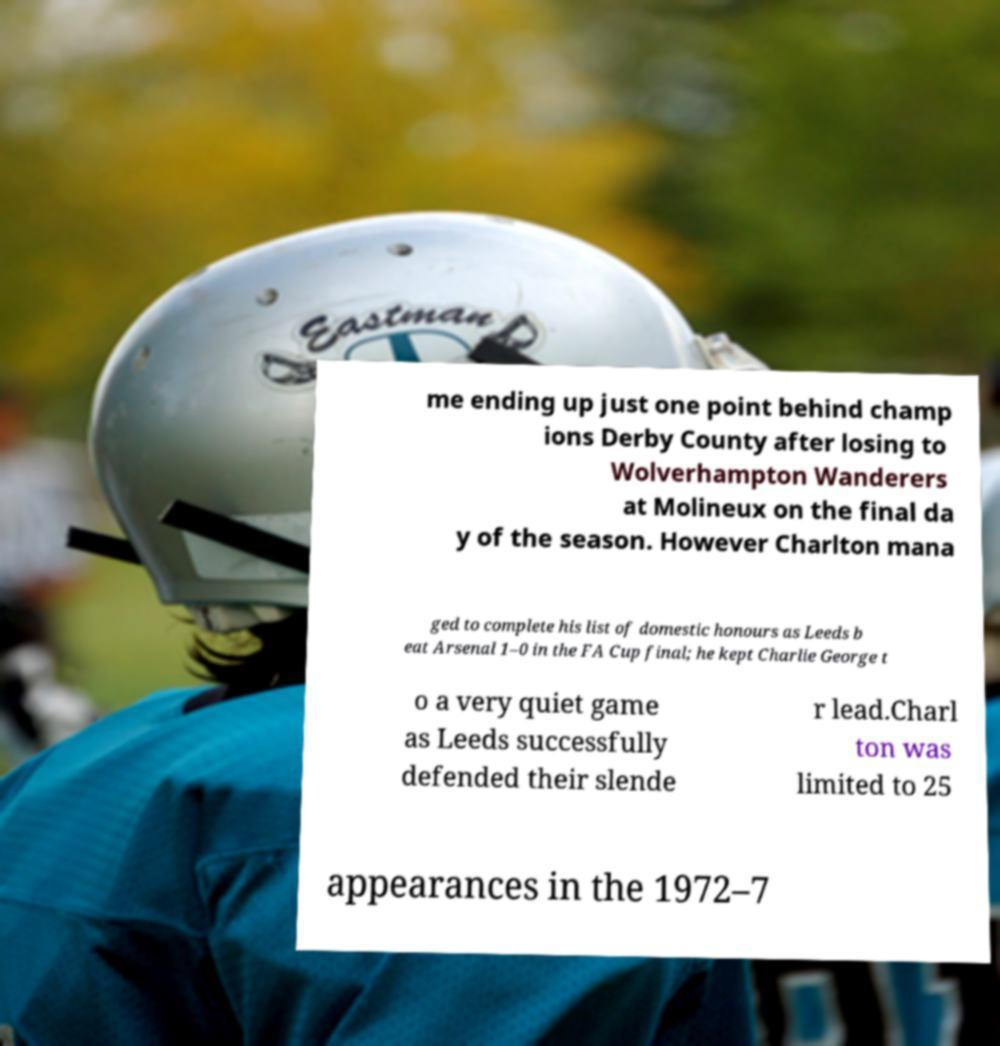What messages or text are displayed in this image? I need them in a readable, typed format. me ending up just one point behind champ ions Derby County after losing to Wolverhampton Wanderers at Molineux on the final da y of the season. However Charlton mana ged to complete his list of domestic honours as Leeds b eat Arsenal 1–0 in the FA Cup final; he kept Charlie George t o a very quiet game as Leeds successfully defended their slende r lead.Charl ton was limited to 25 appearances in the 1972–7 